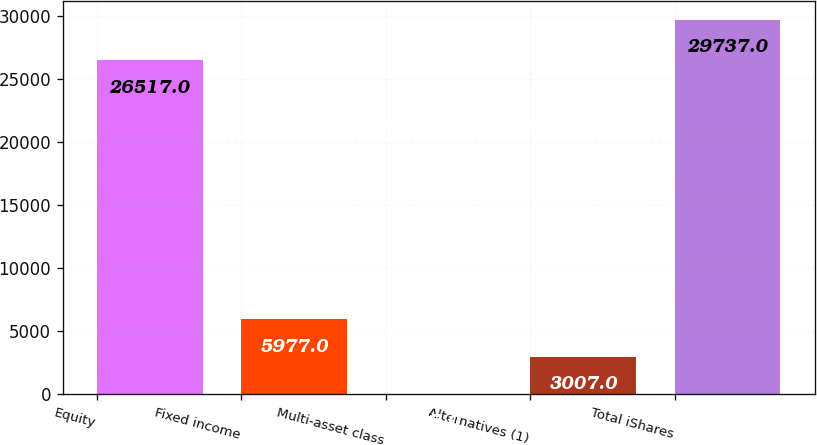<chart> <loc_0><loc_0><loc_500><loc_500><bar_chart><fcel>Equity<fcel>Fixed income<fcel>Multi-asset class<fcel>Alternatives (1)<fcel>Total iShares<nl><fcel>26517<fcel>5977<fcel>37<fcel>3007<fcel>29737<nl></chart> 